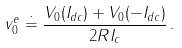Convert formula to latex. <formula><loc_0><loc_0><loc_500><loc_500>v _ { 0 } ^ { e } \doteq \frac { V _ { 0 } ( I _ { d c } ) + V _ { 0 } ( - I _ { d c } ) } { 2 R I _ { c } } \, .</formula> 